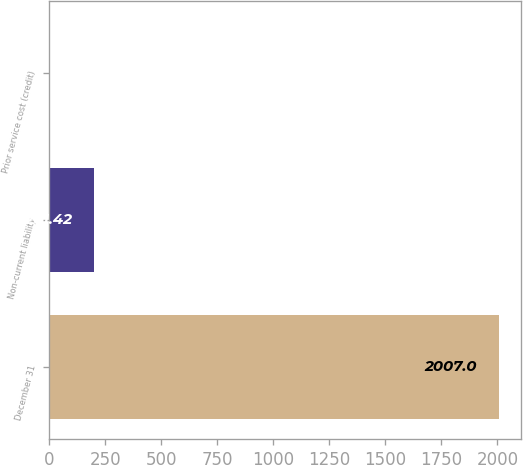Convert chart to OTSL. <chart><loc_0><loc_0><loc_500><loc_500><bar_chart><fcel>December 31<fcel>Non-current liability<fcel>Prior service cost (credit)<nl><fcel>2007<fcel>201.42<fcel>0.8<nl></chart> 